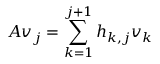<formula> <loc_0><loc_0><loc_500><loc_500>A v _ { j } = \sum _ { k = 1 } ^ { j + 1 } h _ { k , j } v _ { k }</formula> 